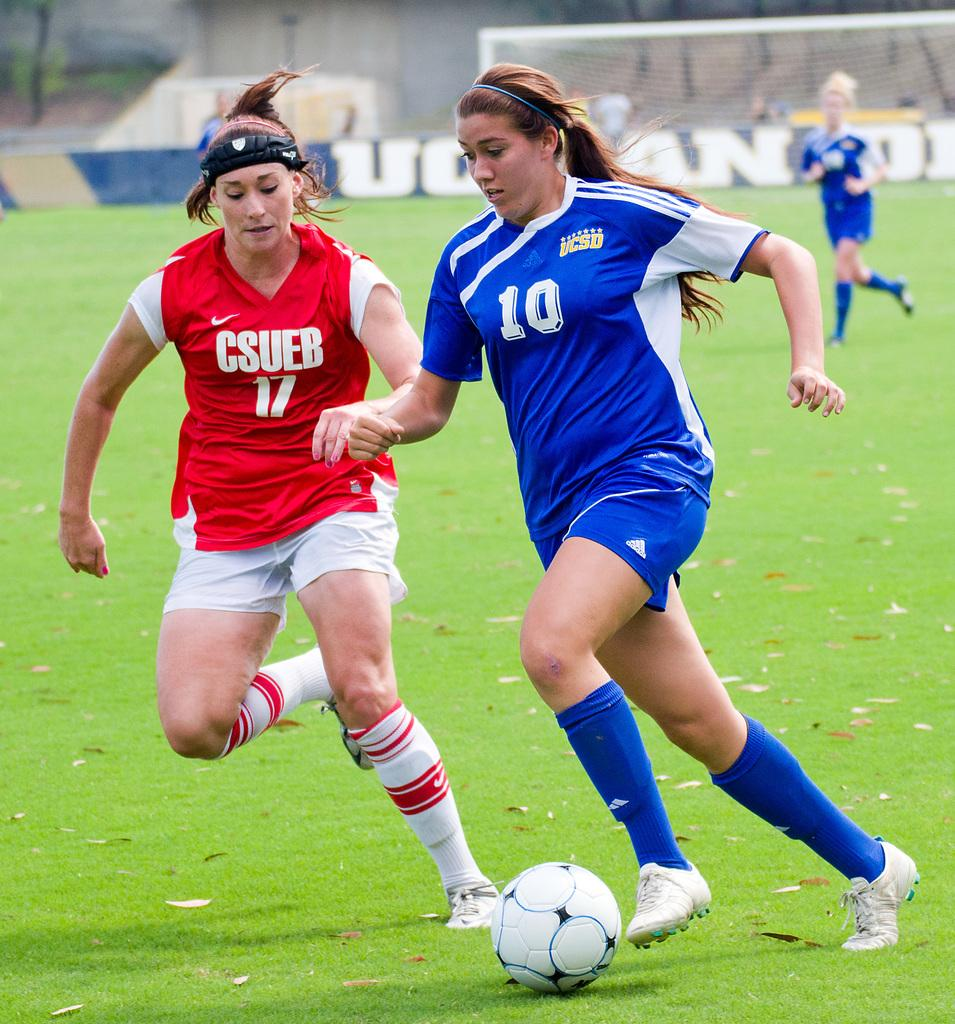What are the 2 women in the image doing? The 2 women in the image are playing football. Can you describe the position of the third woman in the image? There is a woman behind the 2 women playing football. What is the purpose of the structure in the image? There is a goal net in the image, which is used in football games. What can be seen in the background of the image? There are people visible in the background. What type of shelf can be seen holding burnt underwear in the image? There is no shelf, burnt underwear, or any reference to underwear in the image. 